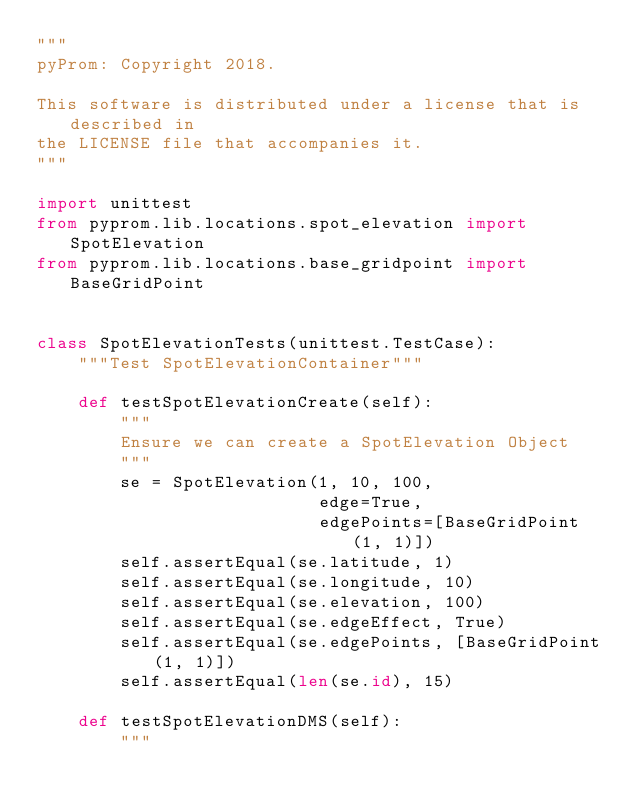Convert code to text. <code><loc_0><loc_0><loc_500><loc_500><_Python_>"""
pyProm: Copyright 2018.

This software is distributed under a license that is described in
the LICENSE file that accompanies it.
"""

import unittest
from pyprom.lib.locations.spot_elevation import SpotElevation
from pyprom.lib.locations.base_gridpoint import BaseGridPoint


class SpotElevationTests(unittest.TestCase):
    """Test SpotElevationContainer"""

    def testSpotElevationCreate(self):
        """
        Ensure we can create a SpotElevation Object
        """
        se = SpotElevation(1, 10, 100,
                           edge=True,
                           edgePoints=[BaseGridPoint(1, 1)])
        self.assertEqual(se.latitude, 1)
        self.assertEqual(se.longitude, 10)
        self.assertEqual(se.elevation, 100)
        self.assertEqual(se.edgeEffect, True)
        self.assertEqual(se.edgePoints, [BaseGridPoint(1, 1)])
        self.assertEqual(len(se.id), 15)

    def testSpotElevationDMS(self):
        """</code> 